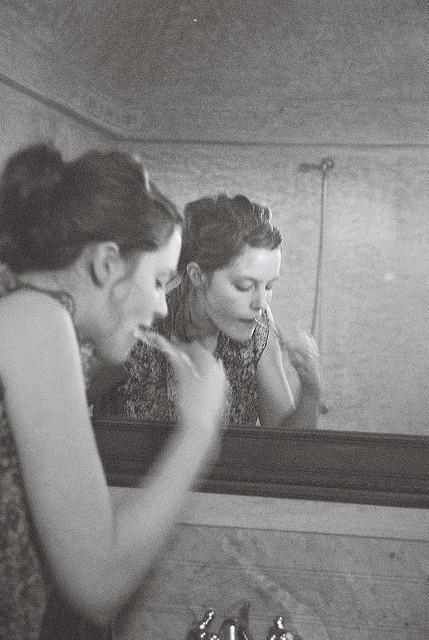How many people are there?
Give a very brief answer. 2. How many giraffes are there?
Give a very brief answer. 0. 